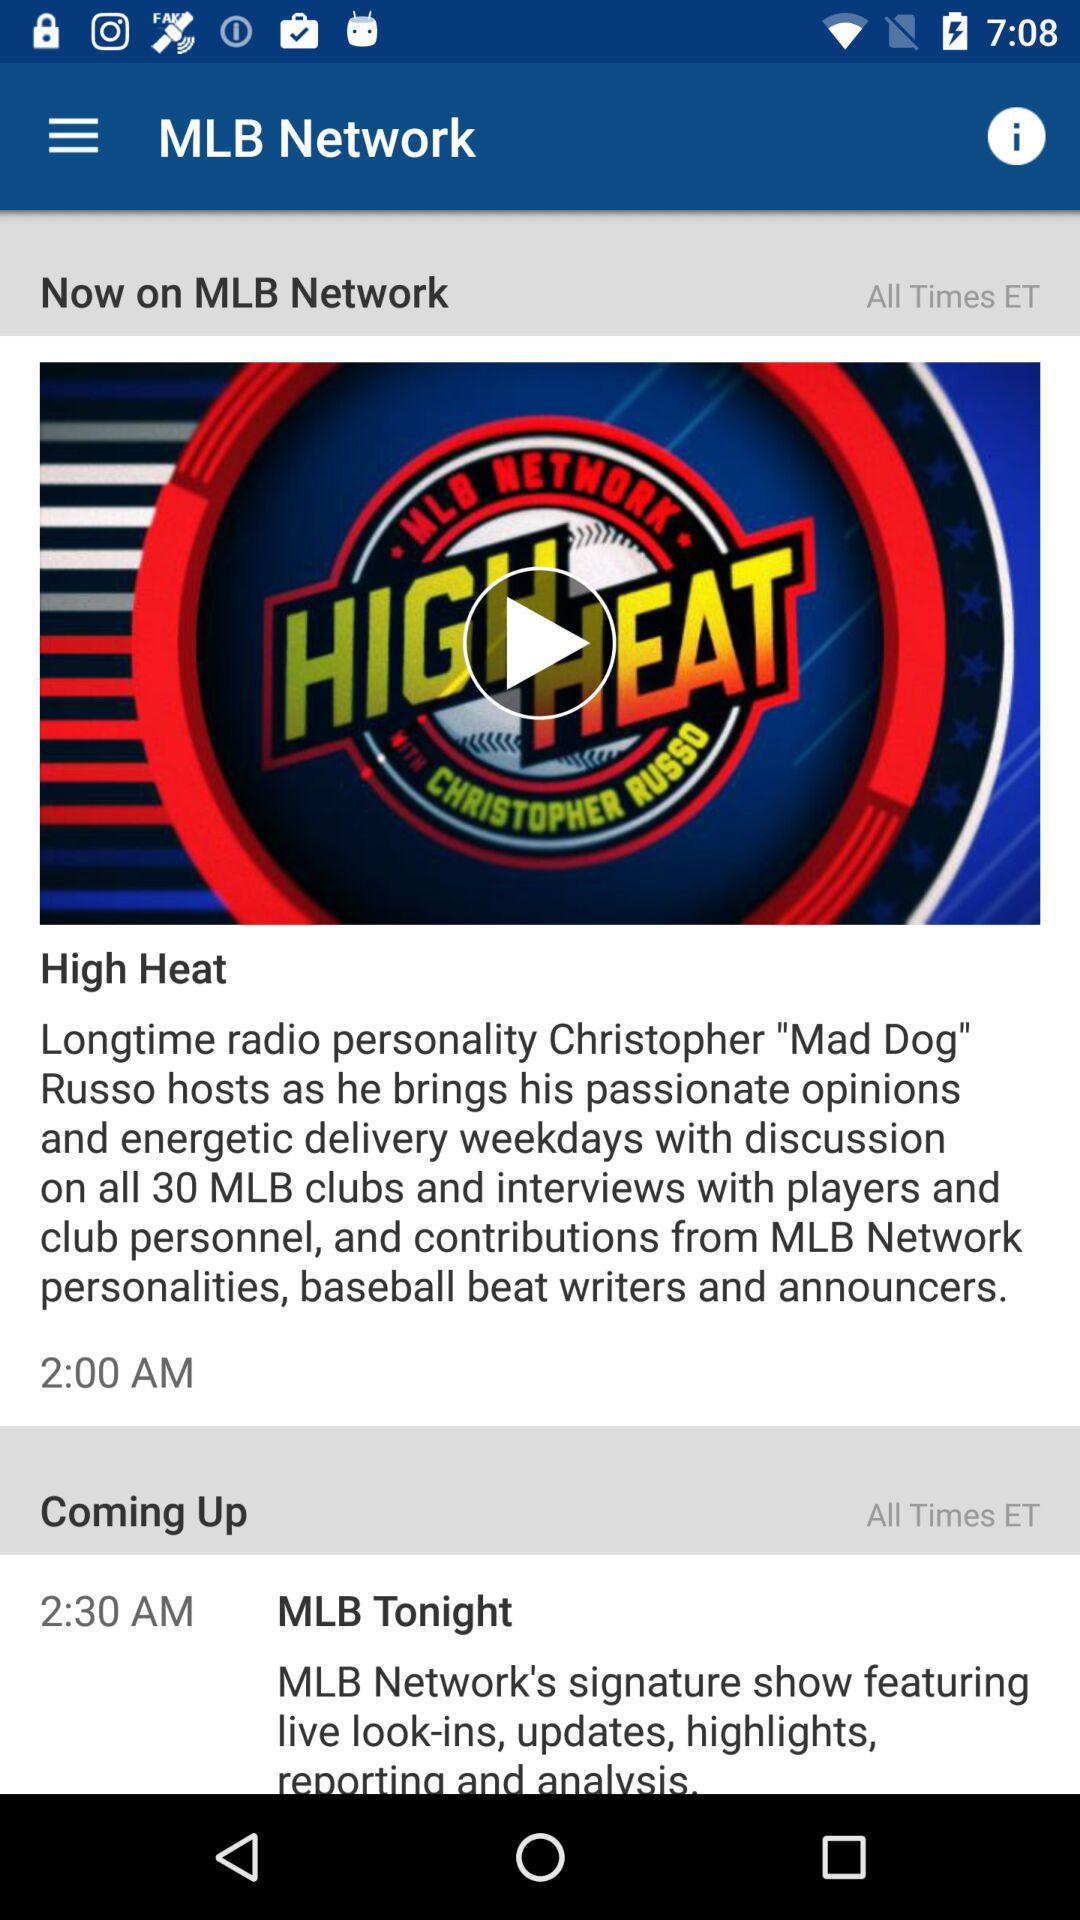What is the time for the upcoming show? The time for the upcoming show is 2:30 AM. 